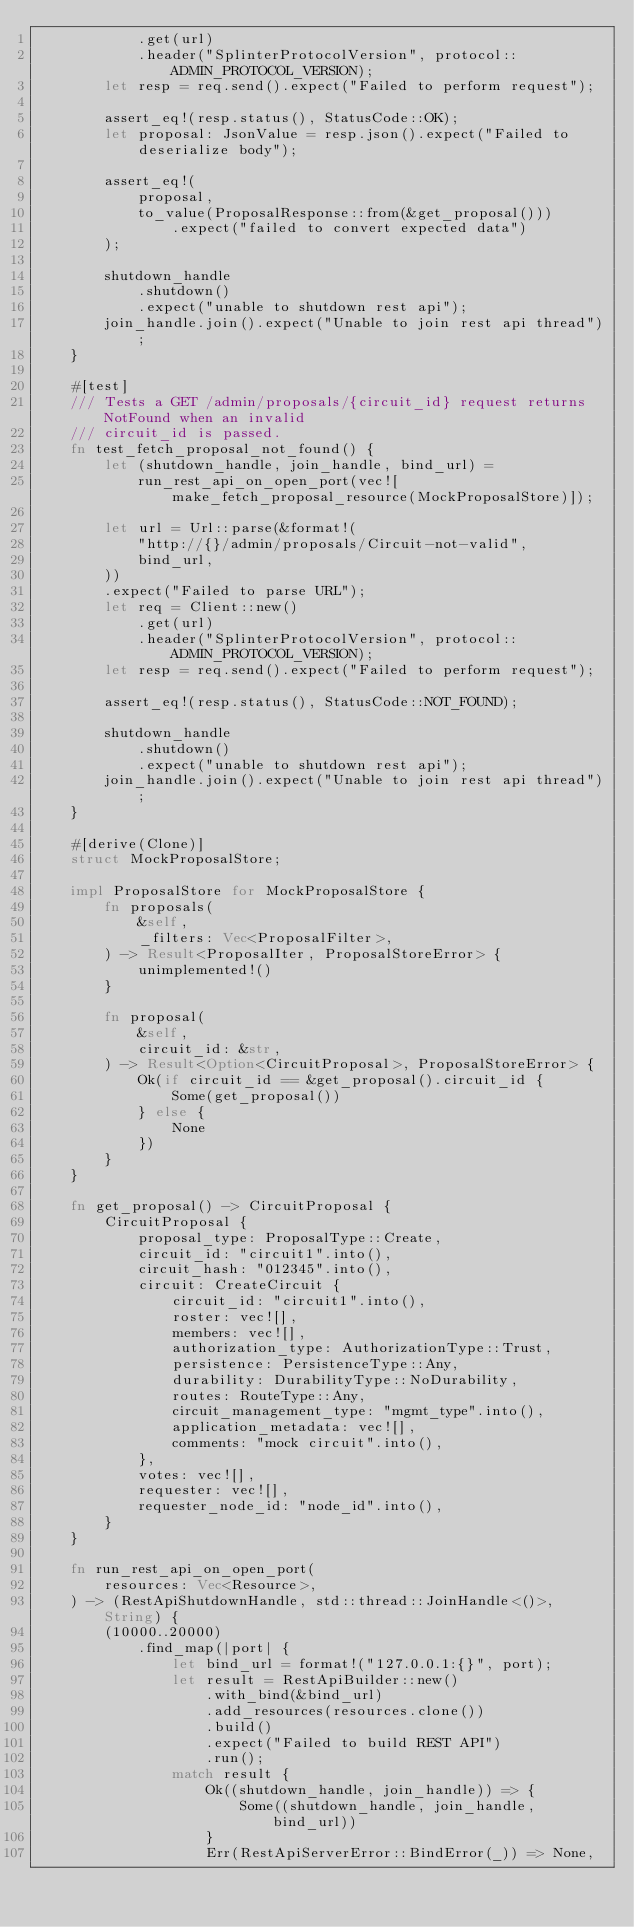<code> <loc_0><loc_0><loc_500><loc_500><_Rust_>            .get(url)
            .header("SplinterProtocolVersion", protocol::ADMIN_PROTOCOL_VERSION);
        let resp = req.send().expect("Failed to perform request");

        assert_eq!(resp.status(), StatusCode::OK);
        let proposal: JsonValue = resp.json().expect("Failed to deserialize body");

        assert_eq!(
            proposal,
            to_value(ProposalResponse::from(&get_proposal()))
                .expect("failed to convert expected data")
        );

        shutdown_handle
            .shutdown()
            .expect("unable to shutdown rest api");
        join_handle.join().expect("Unable to join rest api thread");
    }

    #[test]
    /// Tests a GET /admin/proposals/{circuit_id} request returns NotFound when an invalid
    /// circuit_id is passed.
    fn test_fetch_proposal_not_found() {
        let (shutdown_handle, join_handle, bind_url) =
            run_rest_api_on_open_port(vec![make_fetch_proposal_resource(MockProposalStore)]);

        let url = Url::parse(&format!(
            "http://{}/admin/proposals/Circuit-not-valid",
            bind_url,
        ))
        .expect("Failed to parse URL");
        let req = Client::new()
            .get(url)
            .header("SplinterProtocolVersion", protocol::ADMIN_PROTOCOL_VERSION);
        let resp = req.send().expect("Failed to perform request");

        assert_eq!(resp.status(), StatusCode::NOT_FOUND);

        shutdown_handle
            .shutdown()
            .expect("unable to shutdown rest api");
        join_handle.join().expect("Unable to join rest api thread");
    }

    #[derive(Clone)]
    struct MockProposalStore;

    impl ProposalStore for MockProposalStore {
        fn proposals(
            &self,
            _filters: Vec<ProposalFilter>,
        ) -> Result<ProposalIter, ProposalStoreError> {
            unimplemented!()
        }

        fn proposal(
            &self,
            circuit_id: &str,
        ) -> Result<Option<CircuitProposal>, ProposalStoreError> {
            Ok(if circuit_id == &get_proposal().circuit_id {
                Some(get_proposal())
            } else {
                None
            })
        }
    }

    fn get_proposal() -> CircuitProposal {
        CircuitProposal {
            proposal_type: ProposalType::Create,
            circuit_id: "circuit1".into(),
            circuit_hash: "012345".into(),
            circuit: CreateCircuit {
                circuit_id: "circuit1".into(),
                roster: vec![],
                members: vec![],
                authorization_type: AuthorizationType::Trust,
                persistence: PersistenceType::Any,
                durability: DurabilityType::NoDurability,
                routes: RouteType::Any,
                circuit_management_type: "mgmt_type".into(),
                application_metadata: vec![],
                comments: "mock circuit".into(),
            },
            votes: vec![],
            requester: vec![],
            requester_node_id: "node_id".into(),
        }
    }

    fn run_rest_api_on_open_port(
        resources: Vec<Resource>,
    ) -> (RestApiShutdownHandle, std::thread::JoinHandle<()>, String) {
        (10000..20000)
            .find_map(|port| {
                let bind_url = format!("127.0.0.1:{}", port);
                let result = RestApiBuilder::new()
                    .with_bind(&bind_url)
                    .add_resources(resources.clone())
                    .build()
                    .expect("Failed to build REST API")
                    .run();
                match result {
                    Ok((shutdown_handle, join_handle)) => {
                        Some((shutdown_handle, join_handle, bind_url))
                    }
                    Err(RestApiServerError::BindError(_)) => None,</code> 